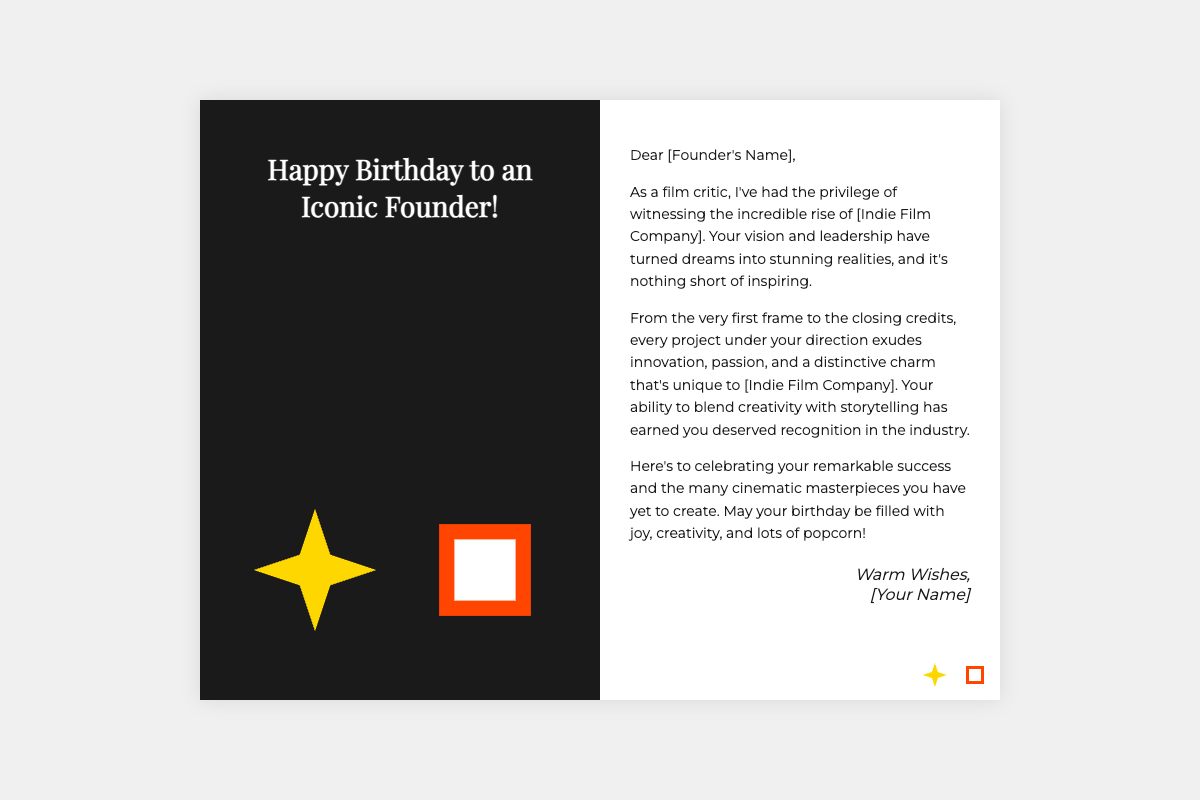What is the title on the front of the card? The title on the front of the card is a birthday greeting directed at the founder, reading "Happy Birthday to an Iconic Founder!".
Answer: Happy Birthday to an Iconic Founder! What illustrations are featured on the front of the card? The front of the card features popcorn and a director's chair as playful illustrations.
Answer: Popcorn and director's chair What color is the front background of the card? The front background of the card is dark-colored, providing contrast to the text and illustrations.
Answer: Black What is the name used in the message to address the founder? In the message, the founder is addressed directly with a placeholder name, "[Founder's Name]".
Answer: [Founder's Name] What has been acknowledged as the founder's contribution in the message? The message acknowledges the founder's vision and leadership that turned dreams into stunning realities.
Answer: Vision and leadership How does the card encourage the founder's future projects? The message expresses hope for more cinematic masterpieces to be created, supporting the idea of future success.
Answer: More cinematic masterpieces What is the closing sentiment of the message? The message concludes with heartfelt wishes for joy, creativity, and lots of popcorn on the founder's birthday.
Answer: Joy, creativity, and lots of popcorn What is displayed in the mini-illustrations at the bottom of the inside of the card? The mini-illustrations at the bottom feature a smaller popcorn and director's chair, consistent with the theme of celebration.
Answer: Mini popcorn and mini chair 